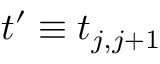Convert formula to latex. <formula><loc_0><loc_0><loc_500><loc_500>t ^ { \prime } \equiv t _ { j , j + 1 }</formula> 